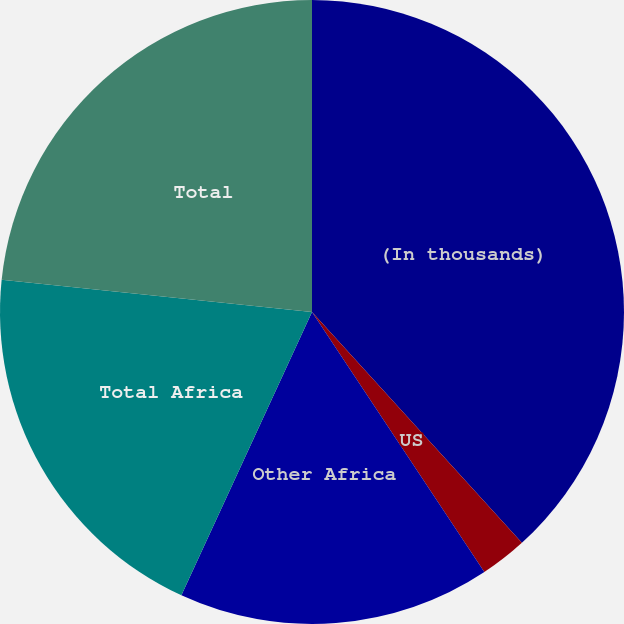Convert chart to OTSL. <chart><loc_0><loc_0><loc_500><loc_500><pie_chart><fcel>(In thousands)<fcel>US<fcel>Other Africa<fcel>Total Africa<fcel>Total<nl><fcel>38.26%<fcel>2.43%<fcel>16.19%<fcel>19.77%<fcel>23.36%<nl></chart> 